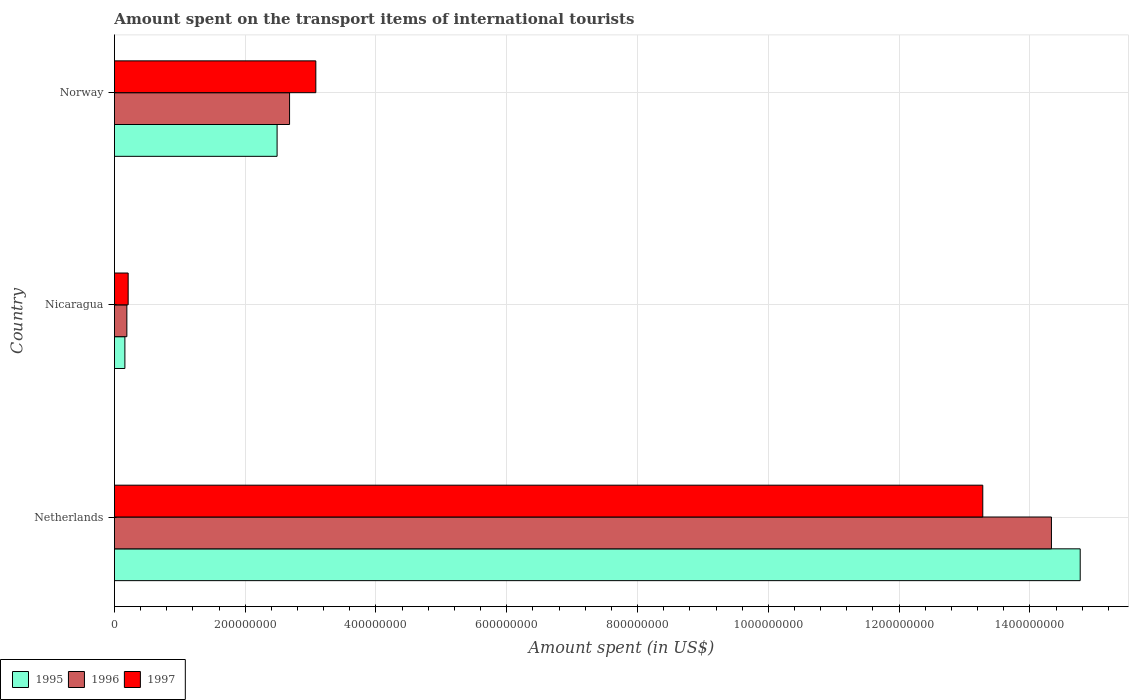How many groups of bars are there?
Make the answer very short. 3. Are the number of bars per tick equal to the number of legend labels?
Keep it short and to the point. Yes. Are the number of bars on each tick of the Y-axis equal?
Your answer should be compact. Yes. How many bars are there on the 3rd tick from the top?
Give a very brief answer. 3. What is the amount spent on the transport items of international tourists in 1997 in Netherlands?
Offer a very short reply. 1.33e+09. Across all countries, what is the maximum amount spent on the transport items of international tourists in 1995?
Provide a short and direct response. 1.48e+09. Across all countries, what is the minimum amount spent on the transport items of international tourists in 1997?
Offer a very short reply. 2.10e+07. In which country was the amount spent on the transport items of international tourists in 1996 minimum?
Keep it short and to the point. Nicaragua. What is the total amount spent on the transport items of international tourists in 1997 in the graph?
Make the answer very short. 1.66e+09. What is the difference between the amount spent on the transport items of international tourists in 1995 in Netherlands and that in Nicaragua?
Provide a short and direct response. 1.46e+09. What is the difference between the amount spent on the transport items of international tourists in 1997 in Netherlands and the amount spent on the transport items of international tourists in 1996 in Nicaragua?
Ensure brevity in your answer.  1.31e+09. What is the average amount spent on the transport items of international tourists in 1995 per country?
Make the answer very short. 5.81e+08. What is the difference between the amount spent on the transport items of international tourists in 1997 and amount spent on the transport items of international tourists in 1996 in Norway?
Offer a terse response. 4.02e+07. In how many countries, is the amount spent on the transport items of international tourists in 1996 greater than 160000000 US$?
Give a very brief answer. 2. What is the ratio of the amount spent on the transport items of international tourists in 1997 in Nicaragua to that in Norway?
Make the answer very short. 0.07. Is the amount spent on the transport items of international tourists in 1997 in Netherlands less than that in Nicaragua?
Your answer should be compact. No. Is the difference between the amount spent on the transport items of international tourists in 1997 in Nicaragua and Norway greater than the difference between the amount spent on the transport items of international tourists in 1996 in Nicaragua and Norway?
Provide a succinct answer. No. What is the difference between the highest and the second highest amount spent on the transport items of international tourists in 1995?
Offer a very short reply. 1.23e+09. What is the difference between the highest and the lowest amount spent on the transport items of international tourists in 1997?
Your answer should be very brief. 1.31e+09. Is the sum of the amount spent on the transport items of international tourists in 1997 in Netherlands and Norway greater than the maximum amount spent on the transport items of international tourists in 1995 across all countries?
Give a very brief answer. Yes. Is it the case that in every country, the sum of the amount spent on the transport items of international tourists in 1995 and amount spent on the transport items of international tourists in 1996 is greater than the amount spent on the transport items of international tourists in 1997?
Your answer should be compact. Yes. How many bars are there?
Your response must be concise. 9. What is the difference between two consecutive major ticks on the X-axis?
Your response must be concise. 2.00e+08. Does the graph contain grids?
Keep it short and to the point. Yes. Where does the legend appear in the graph?
Give a very brief answer. Bottom left. How many legend labels are there?
Your answer should be very brief. 3. What is the title of the graph?
Give a very brief answer. Amount spent on the transport items of international tourists. What is the label or title of the X-axis?
Offer a terse response. Amount spent (in US$). What is the Amount spent (in US$) in 1995 in Netherlands?
Ensure brevity in your answer.  1.48e+09. What is the Amount spent (in US$) of 1996 in Netherlands?
Your answer should be compact. 1.43e+09. What is the Amount spent (in US$) of 1997 in Netherlands?
Make the answer very short. 1.33e+09. What is the Amount spent (in US$) in 1995 in Nicaragua?
Your answer should be very brief. 1.60e+07. What is the Amount spent (in US$) in 1996 in Nicaragua?
Provide a succinct answer. 1.90e+07. What is the Amount spent (in US$) of 1997 in Nicaragua?
Offer a very short reply. 2.10e+07. What is the Amount spent (in US$) of 1995 in Norway?
Your answer should be compact. 2.49e+08. What is the Amount spent (in US$) of 1996 in Norway?
Give a very brief answer. 2.68e+08. What is the Amount spent (in US$) of 1997 in Norway?
Provide a short and direct response. 3.08e+08. Across all countries, what is the maximum Amount spent (in US$) of 1995?
Provide a short and direct response. 1.48e+09. Across all countries, what is the maximum Amount spent (in US$) of 1996?
Offer a terse response. 1.43e+09. Across all countries, what is the maximum Amount spent (in US$) of 1997?
Offer a terse response. 1.33e+09. Across all countries, what is the minimum Amount spent (in US$) of 1995?
Your answer should be very brief. 1.60e+07. Across all countries, what is the minimum Amount spent (in US$) in 1996?
Provide a short and direct response. 1.90e+07. Across all countries, what is the minimum Amount spent (in US$) in 1997?
Your answer should be very brief. 2.10e+07. What is the total Amount spent (in US$) in 1995 in the graph?
Your answer should be compact. 1.74e+09. What is the total Amount spent (in US$) in 1996 in the graph?
Your answer should be compact. 1.72e+09. What is the total Amount spent (in US$) in 1997 in the graph?
Keep it short and to the point. 1.66e+09. What is the difference between the Amount spent (in US$) of 1995 in Netherlands and that in Nicaragua?
Your answer should be very brief. 1.46e+09. What is the difference between the Amount spent (in US$) in 1996 in Netherlands and that in Nicaragua?
Provide a succinct answer. 1.41e+09. What is the difference between the Amount spent (in US$) of 1997 in Netherlands and that in Nicaragua?
Your answer should be very brief. 1.31e+09. What is the difference between the Amount spent (in US$) in 1995 in Netherlands and that in Norway?
Give a very brief answer. 1.23e+09. What is the difference between the Amount spent (in US$) of 1996 in Netherlands and that in Norway?
Offer a terse response. 1.17e+09. What is the difference between the Amount spent (in US$) of 1997 in Netherlands and that in Norway?
Provide a short and direct response. 1.02e+09. What is the difference between the Amount spent (in US$) of 1995 in Nicaragua and that in Norway?
Offer a terse response. -2.33e+08. What is the difference between the Amount spent (in US$) in 1996 in Nicaragua and that in Norway?
Your answer should be very brief. -2.49e+08. What is the difference between the Amount spent (in US$) of 1997 in Nicaragua and that in Norway?
Your response must be concise. -2.87e+08. What is the difference between the Amount spent (in US$) in 1995 in Netherlands and the Amount spent (in US$) in 1996 in Nicaragua?
Your response must be concise. 1.46e+09. What is the difference between the Amount spent (in US$) in 1995 in Netherlands and the Amount spent (in US$) in 1997 in Nicaragua?
Give a very brief answer. 1.46e+09. What is the difference between the Amount spent (in US$) of 1996 in Netherlands and the Amount spent (in US$) of 1997 in Nicaragua?
Your answer should be very brief. 1.41e+09. What is the difference between the Amount spent (in US$) of 1995 in Netherlands and the Amount spent (in US$) of 1996 in Norway?
Give a very brief answer. 1.21e+09. What is the difference between the Amount spent (in US$) in 1995 in Netherlands and the Amount spent (in US$) in 1997 in Norway?
Offer a very short reply. 1.17e+09. What is the difference between the Amount spent (in US$) in 1996 in Netherlands and the Amount spent (in US$) in 1997 in Norway?
Keep it short and to the point. 1.12e+09. What is the difference between the Amount spent (in US$) of 1995 in Nicaragua and the Amount spent (in US$) of 1996 in Norway?
Your answer should be very brief. -2.52e+08. What is the difference between the Amount spent (in US$) in 1995 in Nicaragua and the Amount spent (in US$) in 1997 in Norway?
Your answer should be compact. -2.92e+08. What is the difference between the Amount spent (in US$) in 1996 in Nicaragua and the Amount spent (in US$) in 1997 in Norway?
Keep it short and to the point. -2.89e+08. What is the average Amount spent (in US$) in 1995 per country?
Your answer should be very brief. 5.81e+08. What is the average Amount spent (in US$) of 1996 per country?
Your answer should be very brief. 5.73e+08. What is the average Amount spent (in US$) in 1997 per country?
Provide a short and direct response. 5.52e+08. What is the difference between the Amount spent (in US$) in 1995 and Amount spent (in US$) in 1996 in Netherlands?
Give a very brief answer. 4.40e+07. What is the difference between the Amount spent (in US$) of 1995 and Amount spent (in US$) of 1997 in Netherlands?
Give a very brief answer. 1.49e+08. What is the difference between the Amount spent (in US$) of 1996 and Amount spent (in US$) of 1997 in Netherlands?
Your response must be concise. 1.05e+08. What is the difference between the Amount spent (in US$) of 1995 and Amount spent (in US$) of 1996 in Nicaragua?
Ensure brevity in your answer.  -3.00e+06. What is the difference between the Amount spent (in US$) in 1995 and Amount spent (in US$) in 1997 in Nicaragua?
Your answer should be compact. -5.00e+06. What is the difference between the Amount spent (in US$) of 1996 and Amount spent (in US$) of 1997 in Nicaragua?
Offer a terse response. -2.00e+06. What is the difference between the Amount spent (in US$) of 1995 and Amount spent (in US$) of 1996 in Norway?
Provide a succinct answer. -1.91e+07. What is the difference between the Amount spent (in US$) in 1995 and Amount spent (in US$) in 1997 in Norway?
Offer a terse response. -5.92e+07. What is the difference between the Amount spent (in US$) of 1996 and Amount spent (in US$) of 1997 in Norway?
Give a very brief answer. -4.02e+07. What is the ratio of the Amount spent (in US$) of 1995 in Netherlands to that in Nicaragua?
Provide a short and direct response. 92.31. What is the ratio of the Amount spent (in US$) in 1996 in Netherlands to that in Nicaragua?
Offer a very short reply. 75.42. What is the ratio of the Amount spent (in US$) in 1997 in Netherlands to that in Nicaragua?
Keep it short and to the point. 63.24. What is the ratio of the Amount spent (in US$) of 1995 in Netherlands to that in Norway?
Offer a very short reply. 5.94. What is the ratio of the Amount spent (in US$) of 1996 in Netherlands to that in Norway?
Give a very brief answer. 5.35. What is the ratio of the Amount spent (in US$) in 1997 in Netherlands to that in Norway?
Keep it short and to the point. 4.31. What is the ratio of the Amount spent (in US$) in 1995 in Nicaragua to that in Norway?
Your response must be concise. 0.06. What is the ratio of the Amount spent (in US$) of 1996 in Nicaragua to that in Norway?
Make the answer very short. 0.07. What is the ratio of the Amount spent (in US$) in 1997 in Nicaragua to that in Norway?
Offer a very short reply. 0.07. What is the difference between the highest and the second highest Amount spent (in US$) in 1995?
Ensure brevity in your answer.  1.23e+09. What is the difference between the highest and the second highest Amount spent (in US$) of 1996?
Your answer should be compact. 1.17e+09. What is the difference between the highest and the second highest Amount spent (in US$) of 1997?
Ensure brevity in your answer.  1.02e+09. What is the difference between the highest and the lowest Amount spent (in US$) in 1995?
Your answer should be compact. 1.46e+09. What is the difference between the highest and the lowest Amount spent (in US$) of 1996?
Provide a succinct answer. 1.41e+09. What is the difference between the highest and the lowest Amount spent (in US$) in 1997?
Provide a succinct answer. 1.31e+09. 